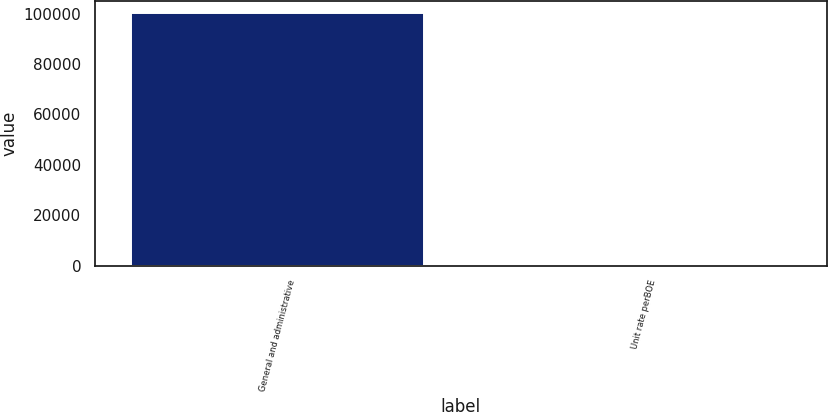Convert chart. <chart><loc_0><loc_0><loc_500><loc_500><bar_chart><fcel>General and administrative<fcel>Unit rate perBOE<nl><fcel>100125<fcel>1.94<nl></chart> 